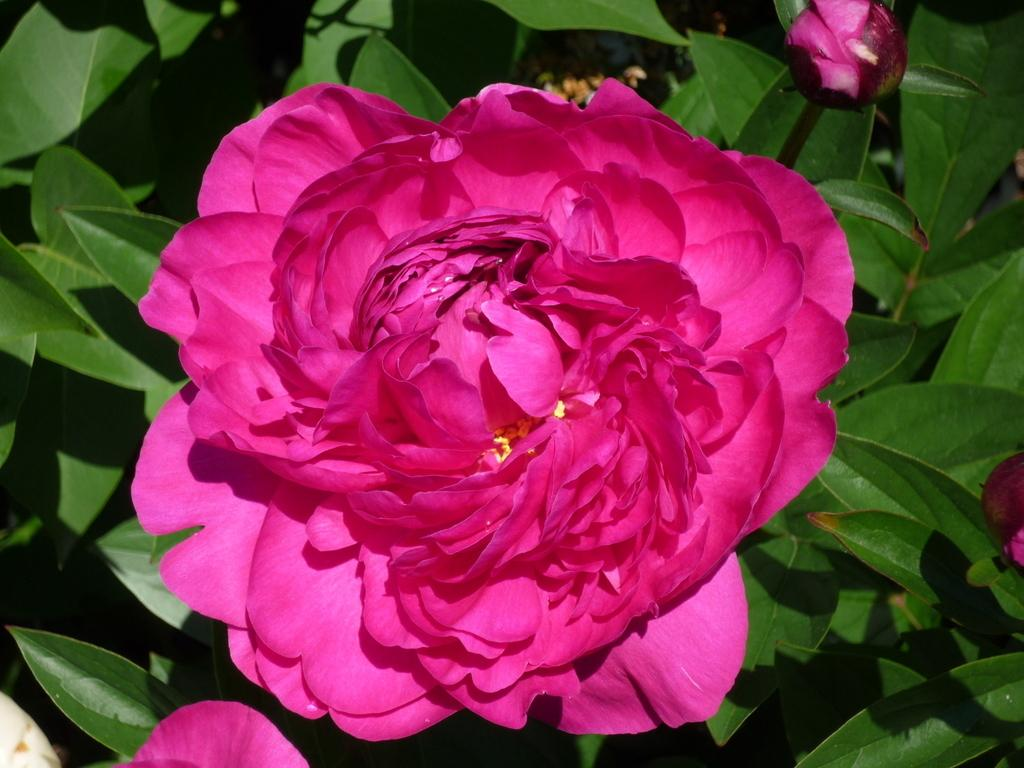What type of flower is in the image? There is a pink rose flower in the image. Where is the flower located? The rose flower is on a plant. What type of horse can be seen holding the flag in the image? There is no horse or flag present in the image; it only features a pink rose flower on a plant. 